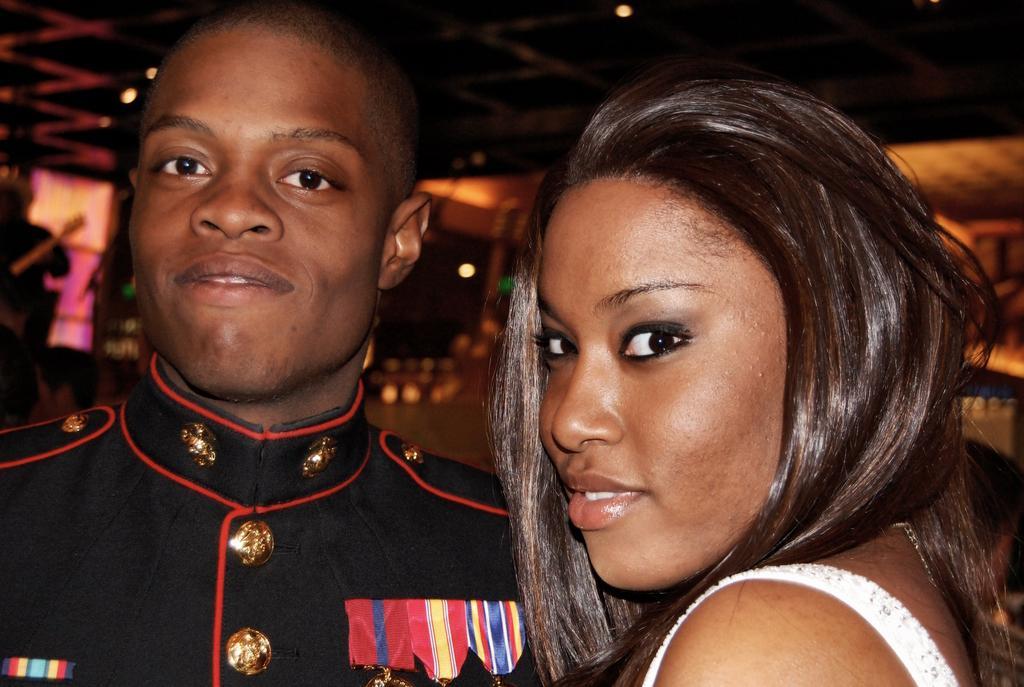Please provide a concise description of this image. In the center of the image there are two persons standing. 